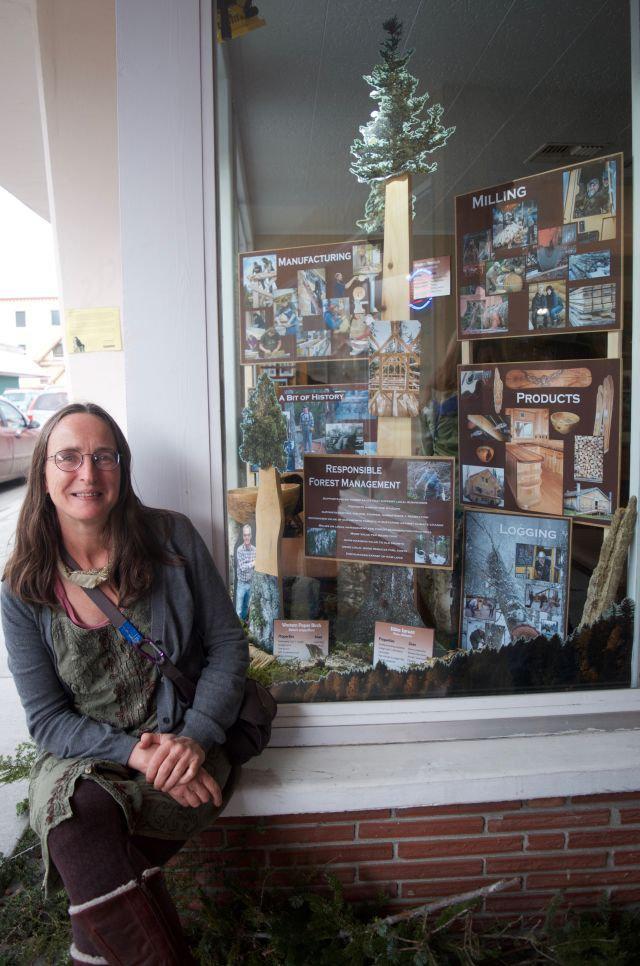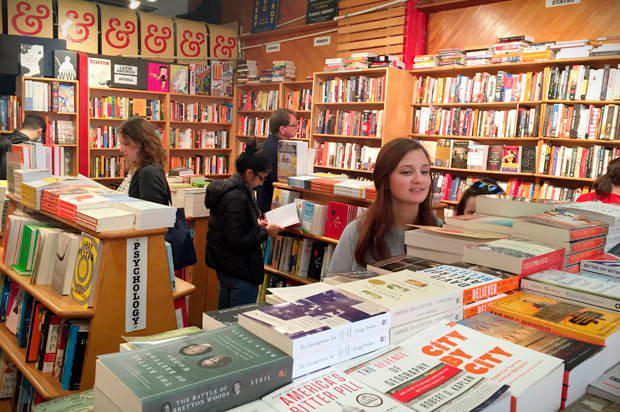The first image is the image on the left, the second image is the image on the right. For the images displayed, is the sentence "A woman in a red blouse is sitting at a table of books in one of the images." factually correct? Answer yes or no. No. The first image is the image on the left, the second image is the image on the right. Considering the images on both sides, is "One image shows a red-headed woman in a reddish dress sitting in front of open boxes of books." valid? Answer yes or no. No. 